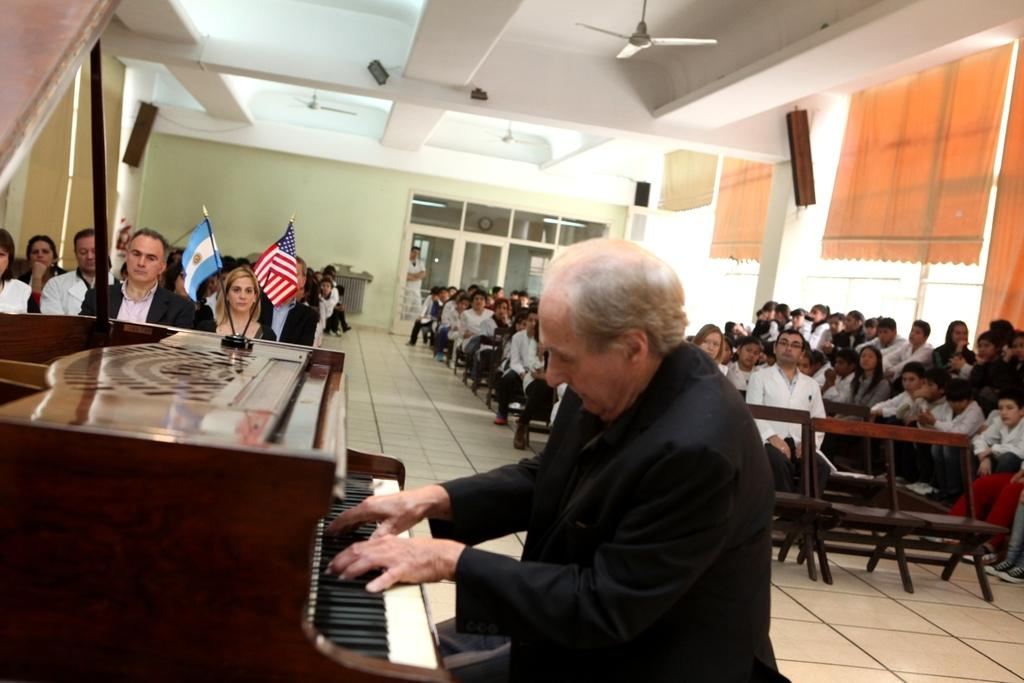What is happening in the image involving a group of people? There is a group of people in the image, and they are sitting on a chair. Can you describe the position of the person in the front of the group? The person in the front of the group is playing a piano. How many people are in the group? The number of people in the group is not specified, but there is a group of people in the image. What color is the shirt worn by the person in the front of the group? The provided facts do not mention the color of the shirt worn by the person in the front of the group. 